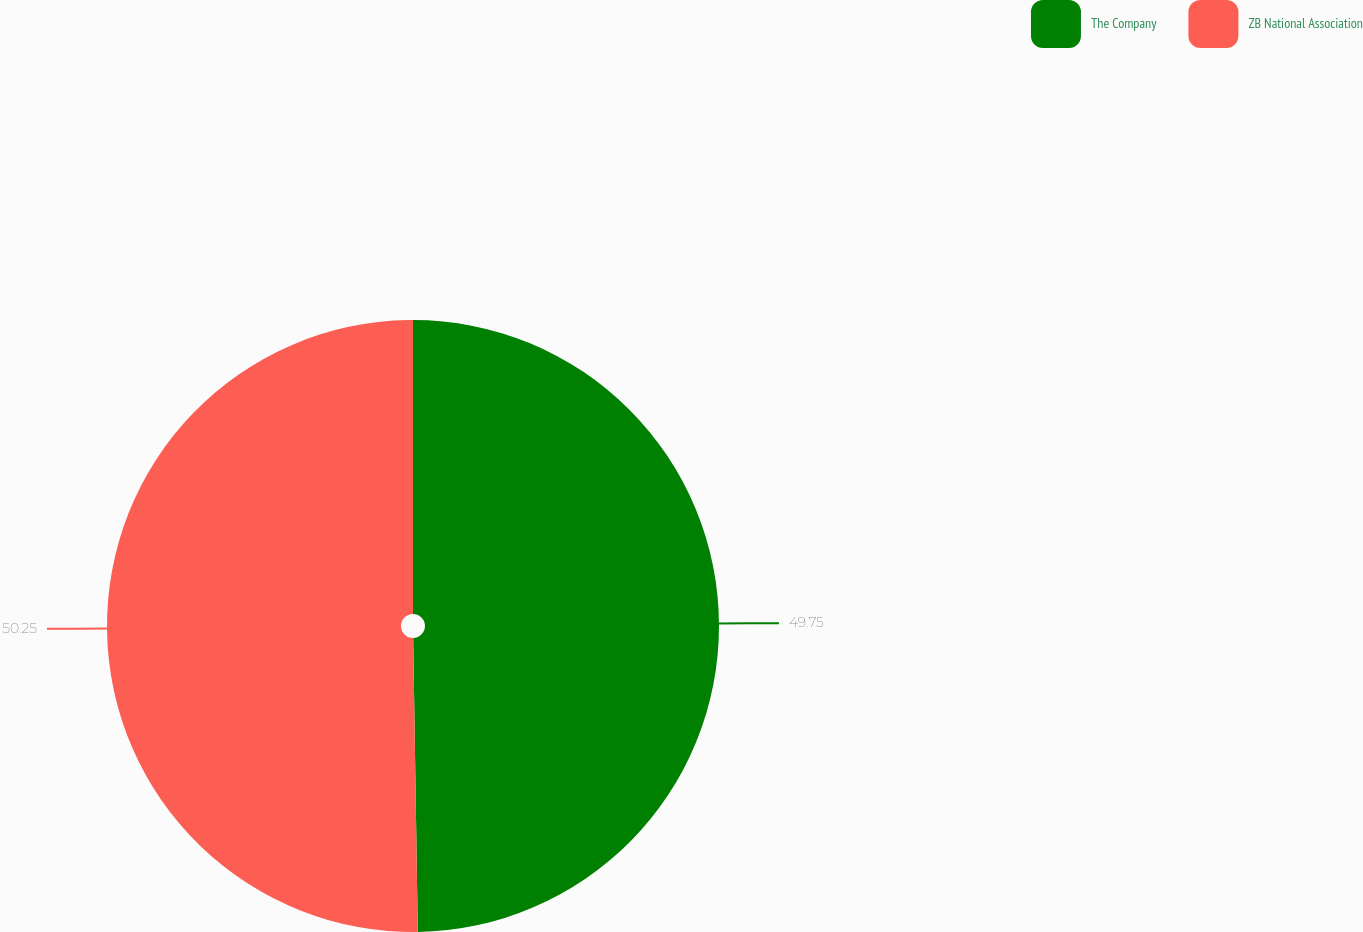Convert chart to OTSL. <chart><loc_0><loc_0><loc_500><loc_500><pie_chart><fcel>The Company<fcel>ZB National Association<nl><fcel>49.75%<fcel>50.25%<nl></chart> 